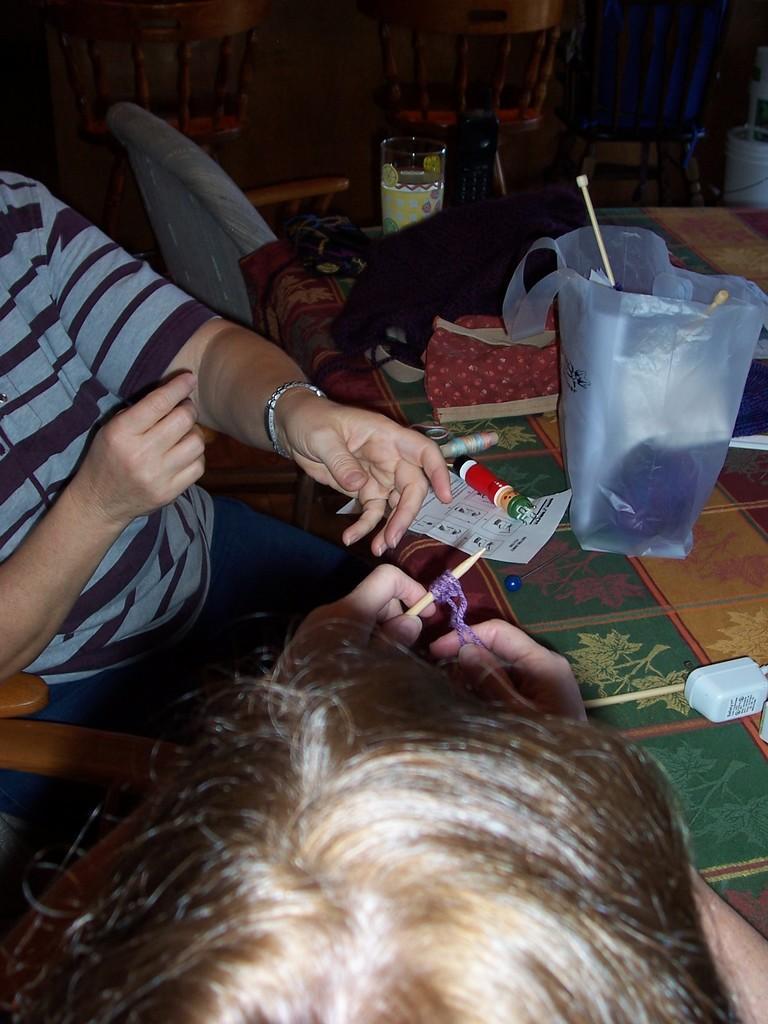Could you give a brief overview of what you see in this image? In this picture we can see there are two people sitting on chairs and in front of the people there is a table and on the table there is a glass, polythene bag, paper, cloth and other things. Behind the people there are chairs. 